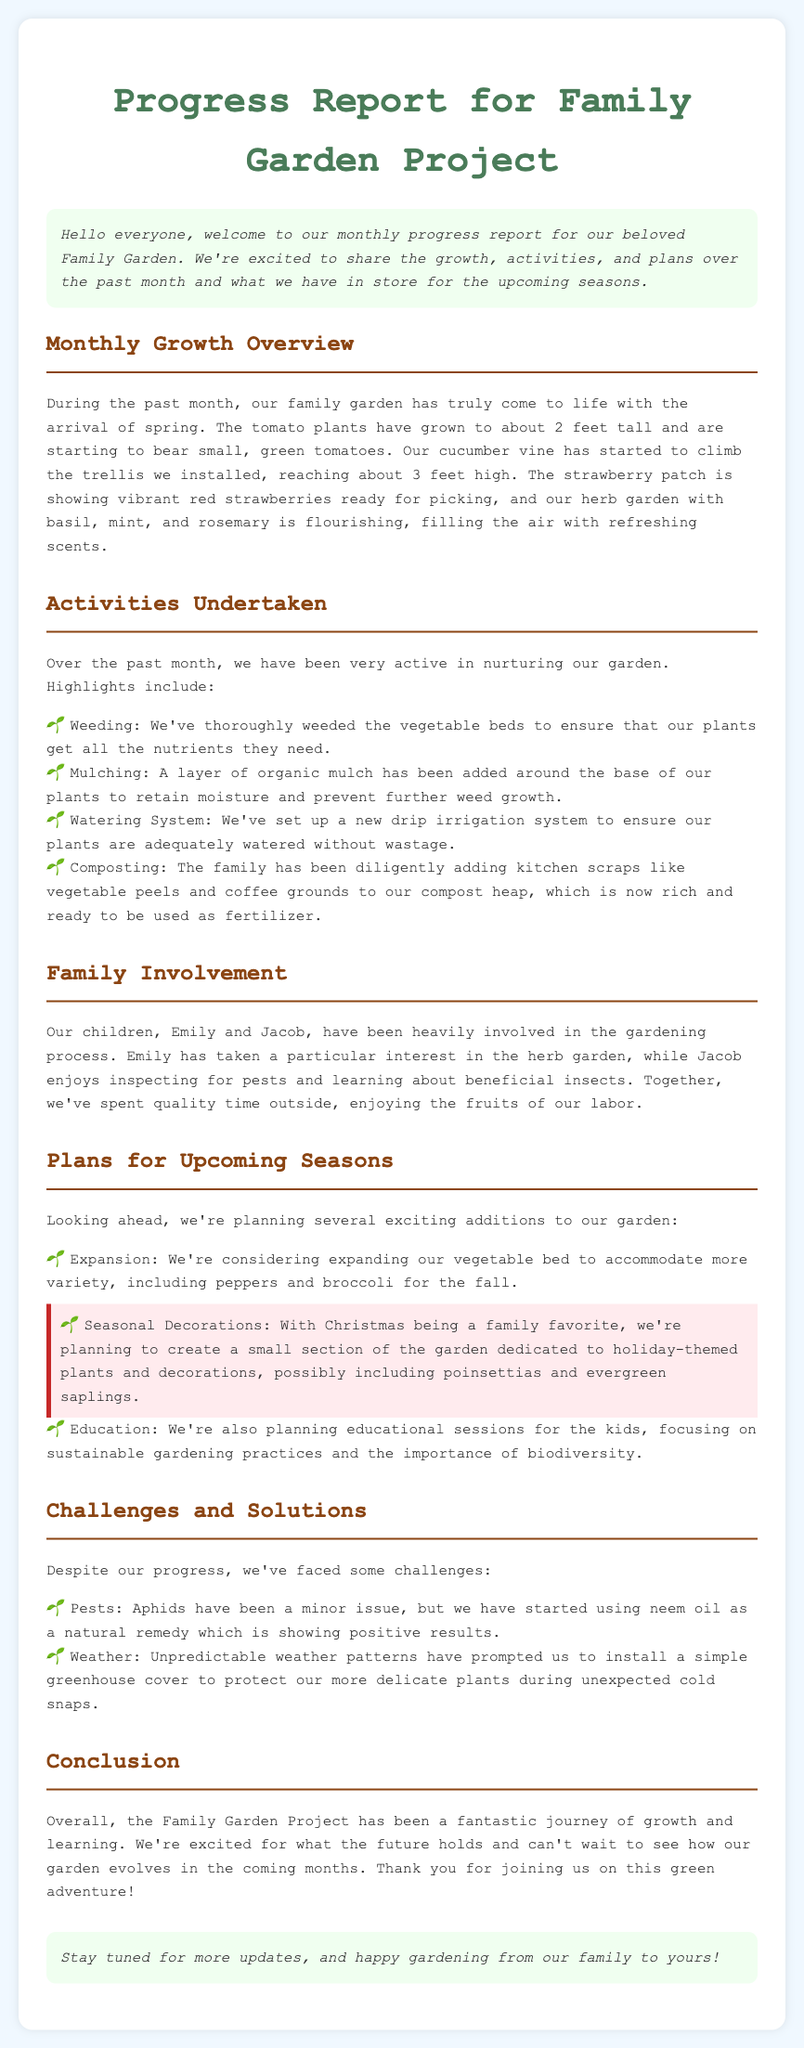What plants are in the herb garden? The document lists basil, mint, and rosemary as the plants in the herb garden.
Answer: basil, mint, and rosemary How tall are the cucumber vines? The cucumber vines are reported to have reached about 3 feet high.
Answer: 3 feet Who has taken an interest in the herb garden? Emily has taken a particular interest in the herb garden.
Answer: Emily What kind of irrigation system was set up? A new drip irrigation system was set up to ensure adequate watering.
Answer: drip irrigation system What challenge is mentioned regarding pests? Aphids have been identified as a minor issue with the plants.
Answer: Aphids What do the kids plan to learn about in upcoming sessions? The kids will focus on sustainable gardening practices.
Answer: sustainable gardening practices Which holiday-themed plants are mentioned for the garden? The garden will potentially include poinsettias and evergreen saplings.
Answer: poinsettias and evergreen saplings What is the purpose of adding organic mulch? The organic mulch retains moisture and prevents further weed growth.
Answer: retain moisture and prevent weed growth 